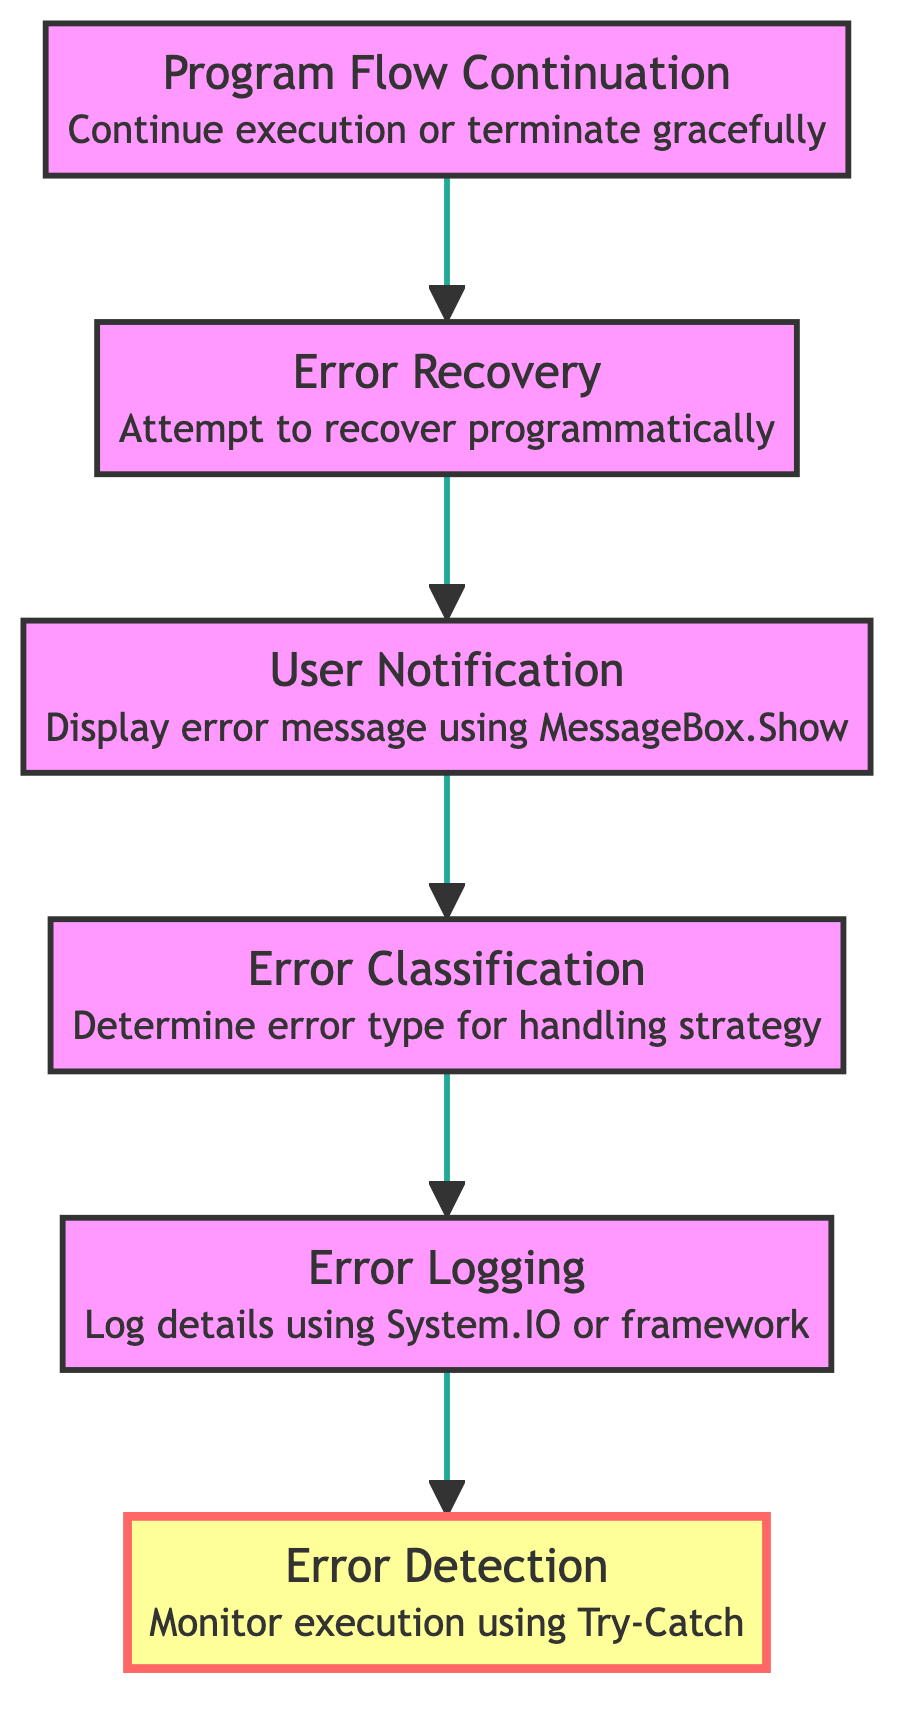What is the starting point of the workflow? The flowchart begins at the "Program Flow Continuation" element, which suggests either continuing execution or terminating gracefully.
Answer: Program Flow Continuation How many elements are in the diagram? The diagram contains six distinct elements, each representing a part of the error handling workflow.
Answer: Six Which element directly follows "Error Classification"? In the flowchart, "Error Logging" is the element that comes directly after "Error Classification".
Answer: Error Logging What action is performed after "User Notification"? After "User Notification", the flow continues to "Error Classification" as the next step in the workflow.
Answer: Error Classification What is the purpose of the "Error Logging" step? The purpose of "Error Logging" is to log error details to a file or database for troubleshooting, as indicated in the diagram.
Answer: Log error details Describe the relationship between "Error Detection" and "Program Flow Continuation". "Error Detection" is the final step that monitors execution using Try-Catch, while "Program Flow Continuation" starts the workflow, highlighting the role of error detection in the overall process. The flow moves from "Error Detection" back to "Program Flow Continuation" indirectly as it influences the program flow.
Answer: Final step influences the initial step What is the significance of the highlighted element in the diagram? The highlighted element, "Error Detection," indicates the crucial step where errors are actively monitored during program execution, showing its importance in the workflow.
Answer: Crucial monitoring step How does the workflow recover from an error? The "Error Recovery" step attempts to recover programmatically, which may involve resetting fields or retrying operations after an error has been detected.
Answer: Attempt to recover programmatically Which step handles user communication? The "User Notification" step is where user communication occurs, displaying an error message using MessageBox.Show with detailed information.
Answer: User Notification 